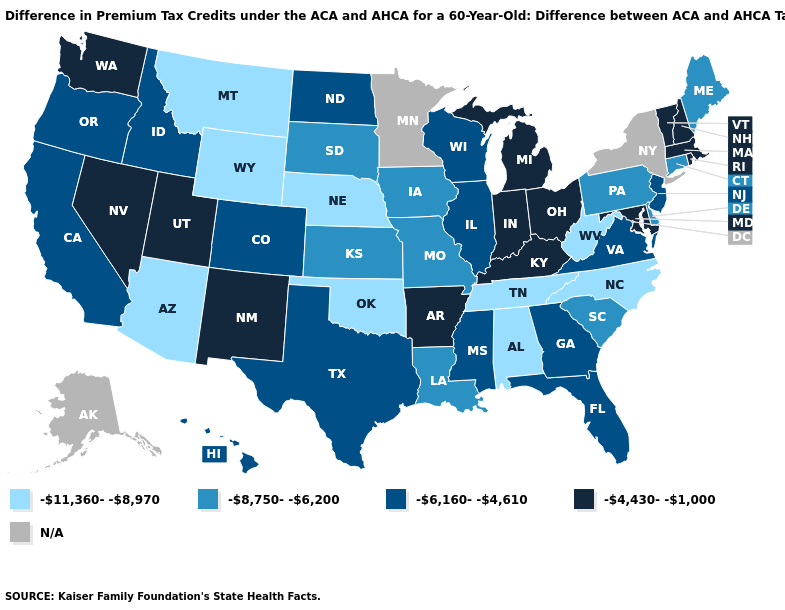What is the highest value in the West ?
Concise answer only. -4,430--1,000. What is the value of Nebraska?
Give a very brief answer. -11,360--8,970. Name the states that have a value in the range -11,360--8,970?
Short answer required. Alabama, Arizona, Montana, Nebraska, North Carolina, Oklahoma, Tennessee, West Virginia, Wyoming. What is the lowest value in the USA?
Be succinct. -11,360--8,970. What is the value of Louisiana?
Concise answer only. -8,750--6,200. What is the lowest value in states that border Delaware?
Concise answer only. -8,750--6,200. Name the states that have a value in the range -8,750--6,200?
Short answer required. Connecticut, Delaware, Iowa, Kansas, Louisiana, Maine, Missouri, Pennsylvania, South Carolina, South Dakota. What is the lowest value in states that border North Dakota?
Concise answer only. -11,360--8,970. How many symbols are there in the legend?
Keep it brief. 5. Is the legend a continuous bar?
Be succinct. No. Does the map have missing data?
Concise answer only. Yes. Which states have the lowest value in the USA?
Answer briefly. Alabama, Arizona, Montana, Nebraska, North Carolina, Oklahoma, Tennessee, West Virginia, Wyoming. Among the states that border New Hampshire , which have the lowest value?
Short answer required. Maine. Among the states that border California , which have the highest value?
Be succinct. Nevada. Name the states that have a value in the range -6,160--4,610?
Write a very short answer. California, Colorado, Florida, Georgia, Hawaii, Idaho, Illinois, Mississippi, New Jersey, North Dakota, Oregon, Texas, Virginia, Wisconsin. 